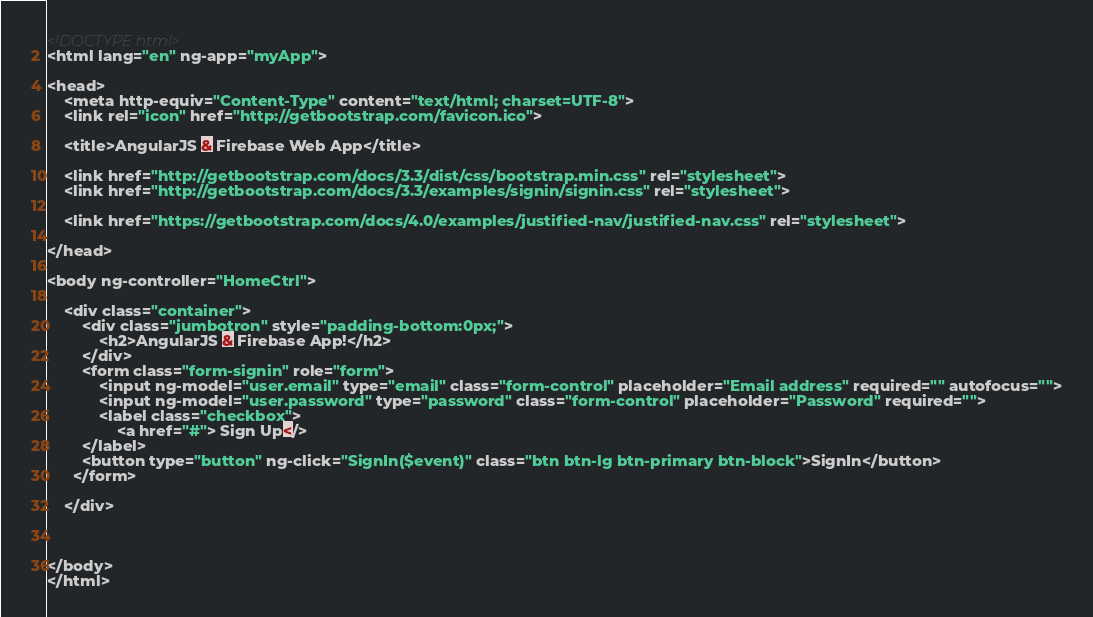<code> <loc_0><loc_0><loc_500><loc_500><_HTML_><!DOCTYPE html>
<html lang="en" ng-app="myApp">
 
<head>
    <meta http-equiv="Content-Type" content="text/html; charset=UTF-8">
    <link rel="icon" href="http://getbootstrap.com/favicon.ico">
 
    <title>AngularJS & Firebase Web App</title>
 
    <link href="http://getbootstrap.com/docs/3.3/dist/css/bootstrap.min.css" rel="stylesheet">
    <link href="http://getbootstrap.com/docs/3.3/examples/signin/signin.css" rel="stylesheet">
 
    <link href="https://getbootstrap.com/docs/4.0/examples/justified-nav/justified-nav.css" rel="stylesheet">
 
</head>
 
<body ng-controller="HomeCtrl">
 
    <div class="container">
        <div class="jumbotron" style="padding-bottom:0px;">
            <h2>AngularJS & Firebase App!</h2>
        </div>
        <form class="form-signin" role="form">
            <input ng-model="user.email" type="email" class="form-control" placeholder="Email address" required="" autofocus="">
            <input ng-model="user.password" type="password" class="form-control" placeholder="Password" required="">
            <label class="checkbox">
                <a href="#"> Sign Up</>
        </label>
        <button type="button" ng-click="SignIn($event)" class="btn btn-lg btn-primary btn-block">SignIn</button>        
      </form>
 
    </div>
 
   
 
</body>
</html></code> 